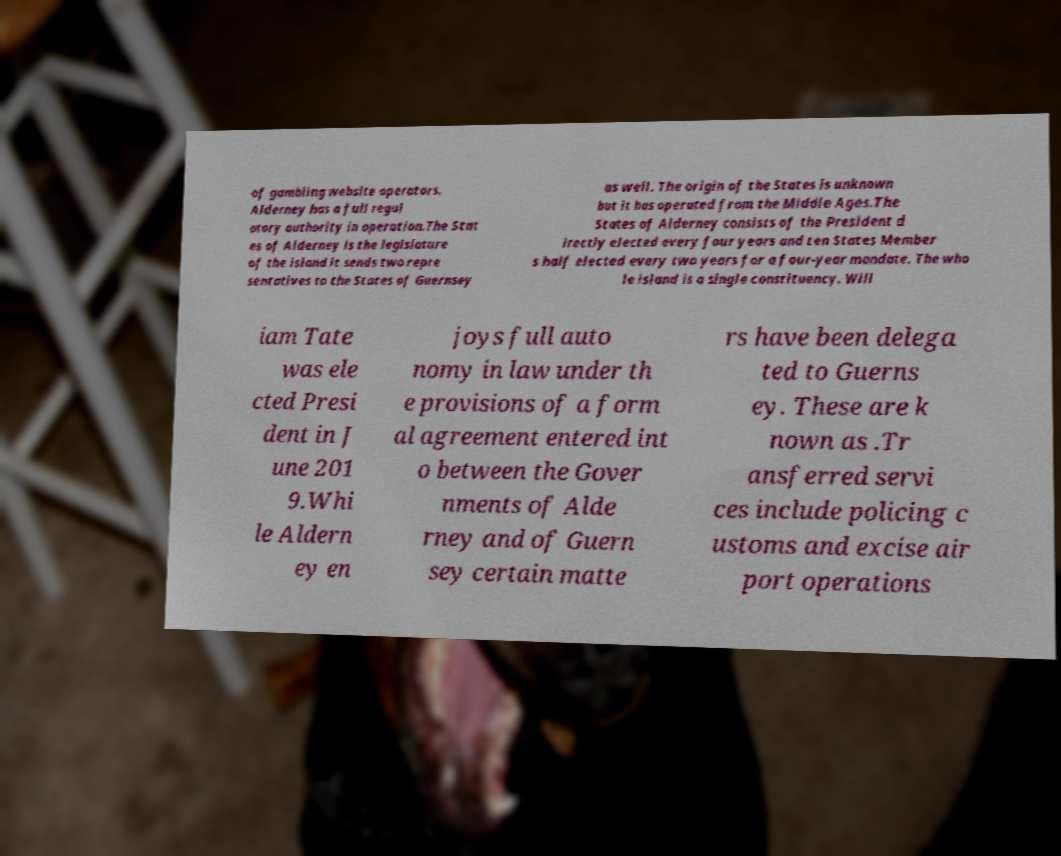Please read and relay the text visible in this image. What does it say? of gambling website operators. Alderney has a full regul atory authority in operation.The Stat es of Alderney is the legislature of the island it sends two repre sentatives to the States of Guernsey as well. The origin of the States is unknown but it has operated from the Middle Ages.The States of Alderney consists of the President d irectly elected every four years and ten States Member s half elected every two years for a four-year mandate. The who le island is a single constituency. Will iam Tate was ele cted Presi dent in J une 201 9.Whi le Aldern ey en joys full auto nomy in law under th e provisions of a form al agreement entered int o between the Gover nments of Alde rney and of Guern sey certain matte rs have been delega ted to Guerns ey. These are k nown as .Tr ansferred servi ces include policing c ustoms and excise air port operations 